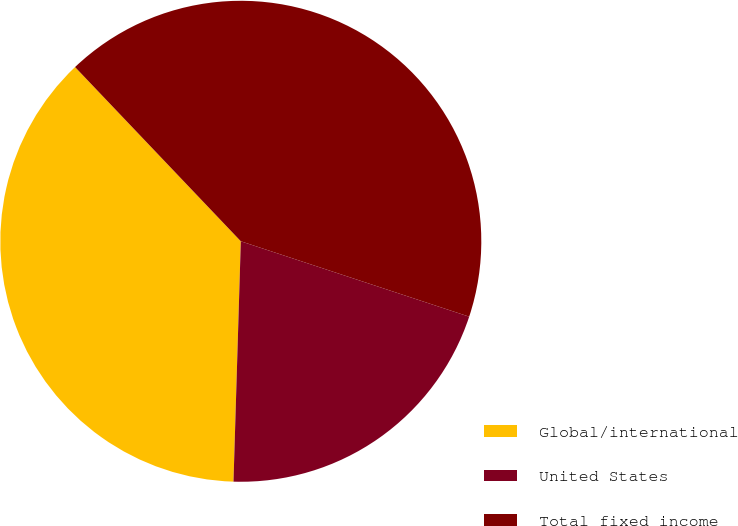<chart> <loc_0><loc_0><loc_500><loc_500><pie_chart><fcel>Global/international<fcel>United States<fcel>Total fixed income<nl><fcel>37.41%<fcel>20.41%<fcel>42.18%<nl></chart> 